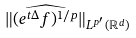Convert formula to latex. <formula><loc_0><loc_0><loc_500><loc_500>\| \widehat { ( e ^ { t \Delta } f ) ^ { 1 / p } } \| _ { L ^ { p ^ { \prime } } ( \mathbb { R } ^ { d } ) }</formula> 